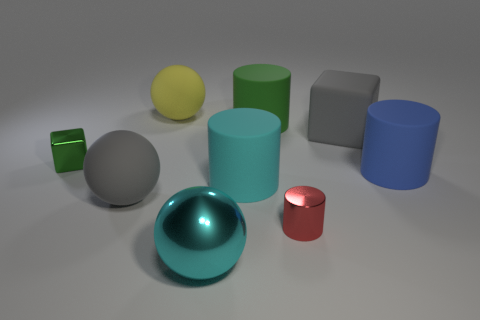Subtract 1 cylinders. How many cylinders are left? 3 Subtract all purple cylinders. Subtract all brown cubes. How many cylinders are left? 4 Add 1 matte spheres. How many objects exist? 10 Subtract all cylinders. How many objects are left? 5 Add 9 big blue cylinders. How many big blue cylinders are left? 10 Add 8 yellow rubber objects. How many yellow rubber objects exist? 9 Subtract 1 yellow balls. How many objects are left? 8 Subtract all cyan rubber blocks. Subtract all big shiny spheres. How many objects are left? 8 